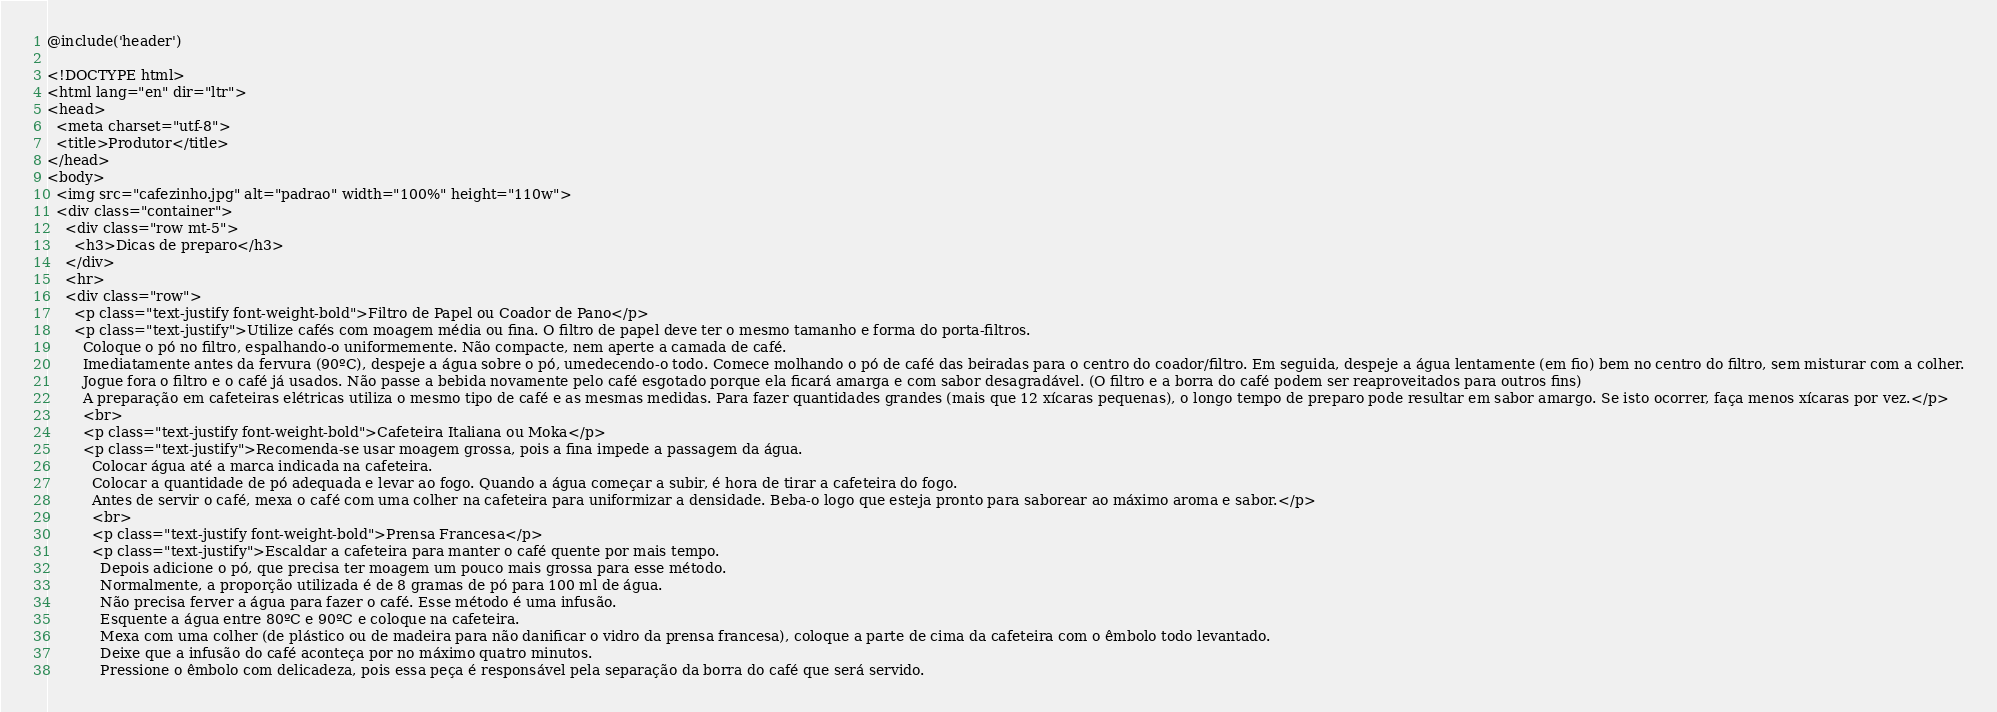<code> <loc_0><loc_0><loc_500><loc_500><_PHP_>@include('header')

<!DOCTYPE html>
<html lang="en" dir="ltr">
<head>
  <meta charset="utf-8">
  <title>Produtor</title>
</head>
<body>
  <img src="cafezinho.jpg" alt="padrao" width="100%" height="110w">
  <div class="container">
    <div class="row mt-5">
      <h3>Dicas de preparo</h3>
    </div>
    <hr>
    <div class="row">
      <p class="text-justify font-weight-bold">Filtro de Papel ou Coador de Pano</p>
      <p class="text-justify">Utilize cafés com moagem média ou fina. O filtro de papel deve ter o mesmo tamanho e forma do porta-filtros.
        Coloque o pó no filtro, espalhando-o uniformemente. Não compacte, nem aperte a camada de café.
        Imediatamente antes da fervura (90ºC), despeje a água sobre o pó, umedecendo-o todo. Comece molhando o pó de café das beiradas para o centro do coador/filtro. Em seguida, despeje a água lentamente (em fio) bem no centro do filtro, sem misturar com a colher.
        Jogue fora o filtro e o café já usados. Não passe a bebida novamente pelo café esgotado porque ela ficará amarga e com sabor desagradável. (O filtro e a borra do café podem ser reaproveitados para outros fins)
        A preparação em cafeteiras elétricas utiliza o mesmo tipo de café e as mesmas medidas. Para fazer quantidades grandes (mais que 12 xícaras pequenas), o longo tempo de preparo pode resultar em sabor amargo. Se isto ocorrer, faça menos xícaras por vez.</p>
        <br>
        <p class="text-justify font-weight-bold">Cafeteira Italiana ou Moka</p>
        <p class="text-justify">Recomenda-se usar moagem grossa, pois a fina impede a passagem da água.
          Colocar água até a marca indicada na cafeteira.
          Colocar a quantidade de pó adequada e levar ao fogo. Quando a água começar a subir, é hora de tirar a cafeteira do fogo.
          Antes de servir o café, mexa o café com uma colher na cafeteira para uniformizar a densidade. Beba-o logo que esteja pronto para saborear ao máximo aroma e sabor.</p>
          <br>
          <p class="text-justify font-weight-bold">Prensa Francesa</p>
          <p class="text-justify">Escaldar a cafeteira para manter o café quente por mais tempo.
            Depois adicione o pó, que precisa ter moagem um pouco mais grossa para esse método.
            Normalmente, a proporção utilizada é de 8 gramas de pó para 100 ml de água.
            Não precisa ferver a água para fazer o café. Esse método é uma infusão.
            Esquente a água entre 80ºC e 90ºC e coloque na cafeteira.
            Mexa com uma colher (de plástico ou de madeira para não danificar o vidro da prensa francesa), coloque a parte de cima da cafeteira com o êmbolo todo levantado.
            Deixe que a infusão do café aconteça por no máximo quatro minutos.
            Pressione o êmbolo com delicadeza, pois essa peça é responsável pela separação da borra do café que será servido.</code> 